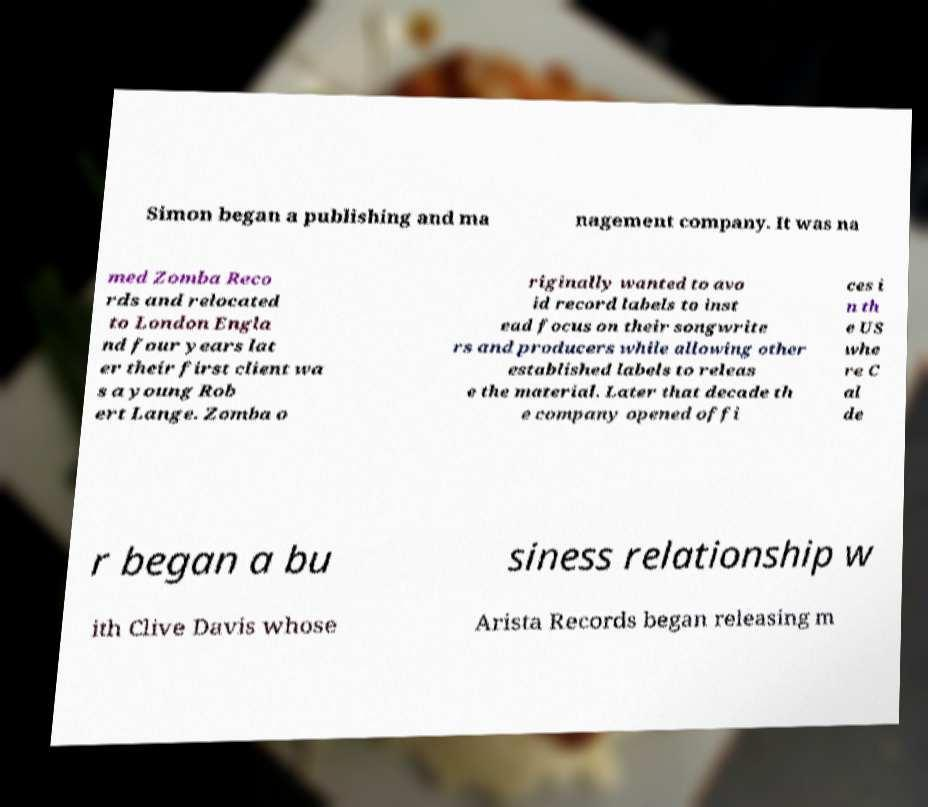There's text embedded in this image that I need extracted. Can you transcribe it verbatim? Simon began a publishing and ma nagement company. It was na med Zomba Reco rds and relocated to London Engla nd four years lat er their first client wa s a young Rob ert Lange. Zomba o riginally wanted to avo id record labels to inst ead focus on their songwrite rs and producers while allowing other established labels to releas e the material. Later that decade th e company opened offi ces i n th e US whe re C al de r began a bu siness relationship w ith Clive Davis whose Arista Records began releasing m 